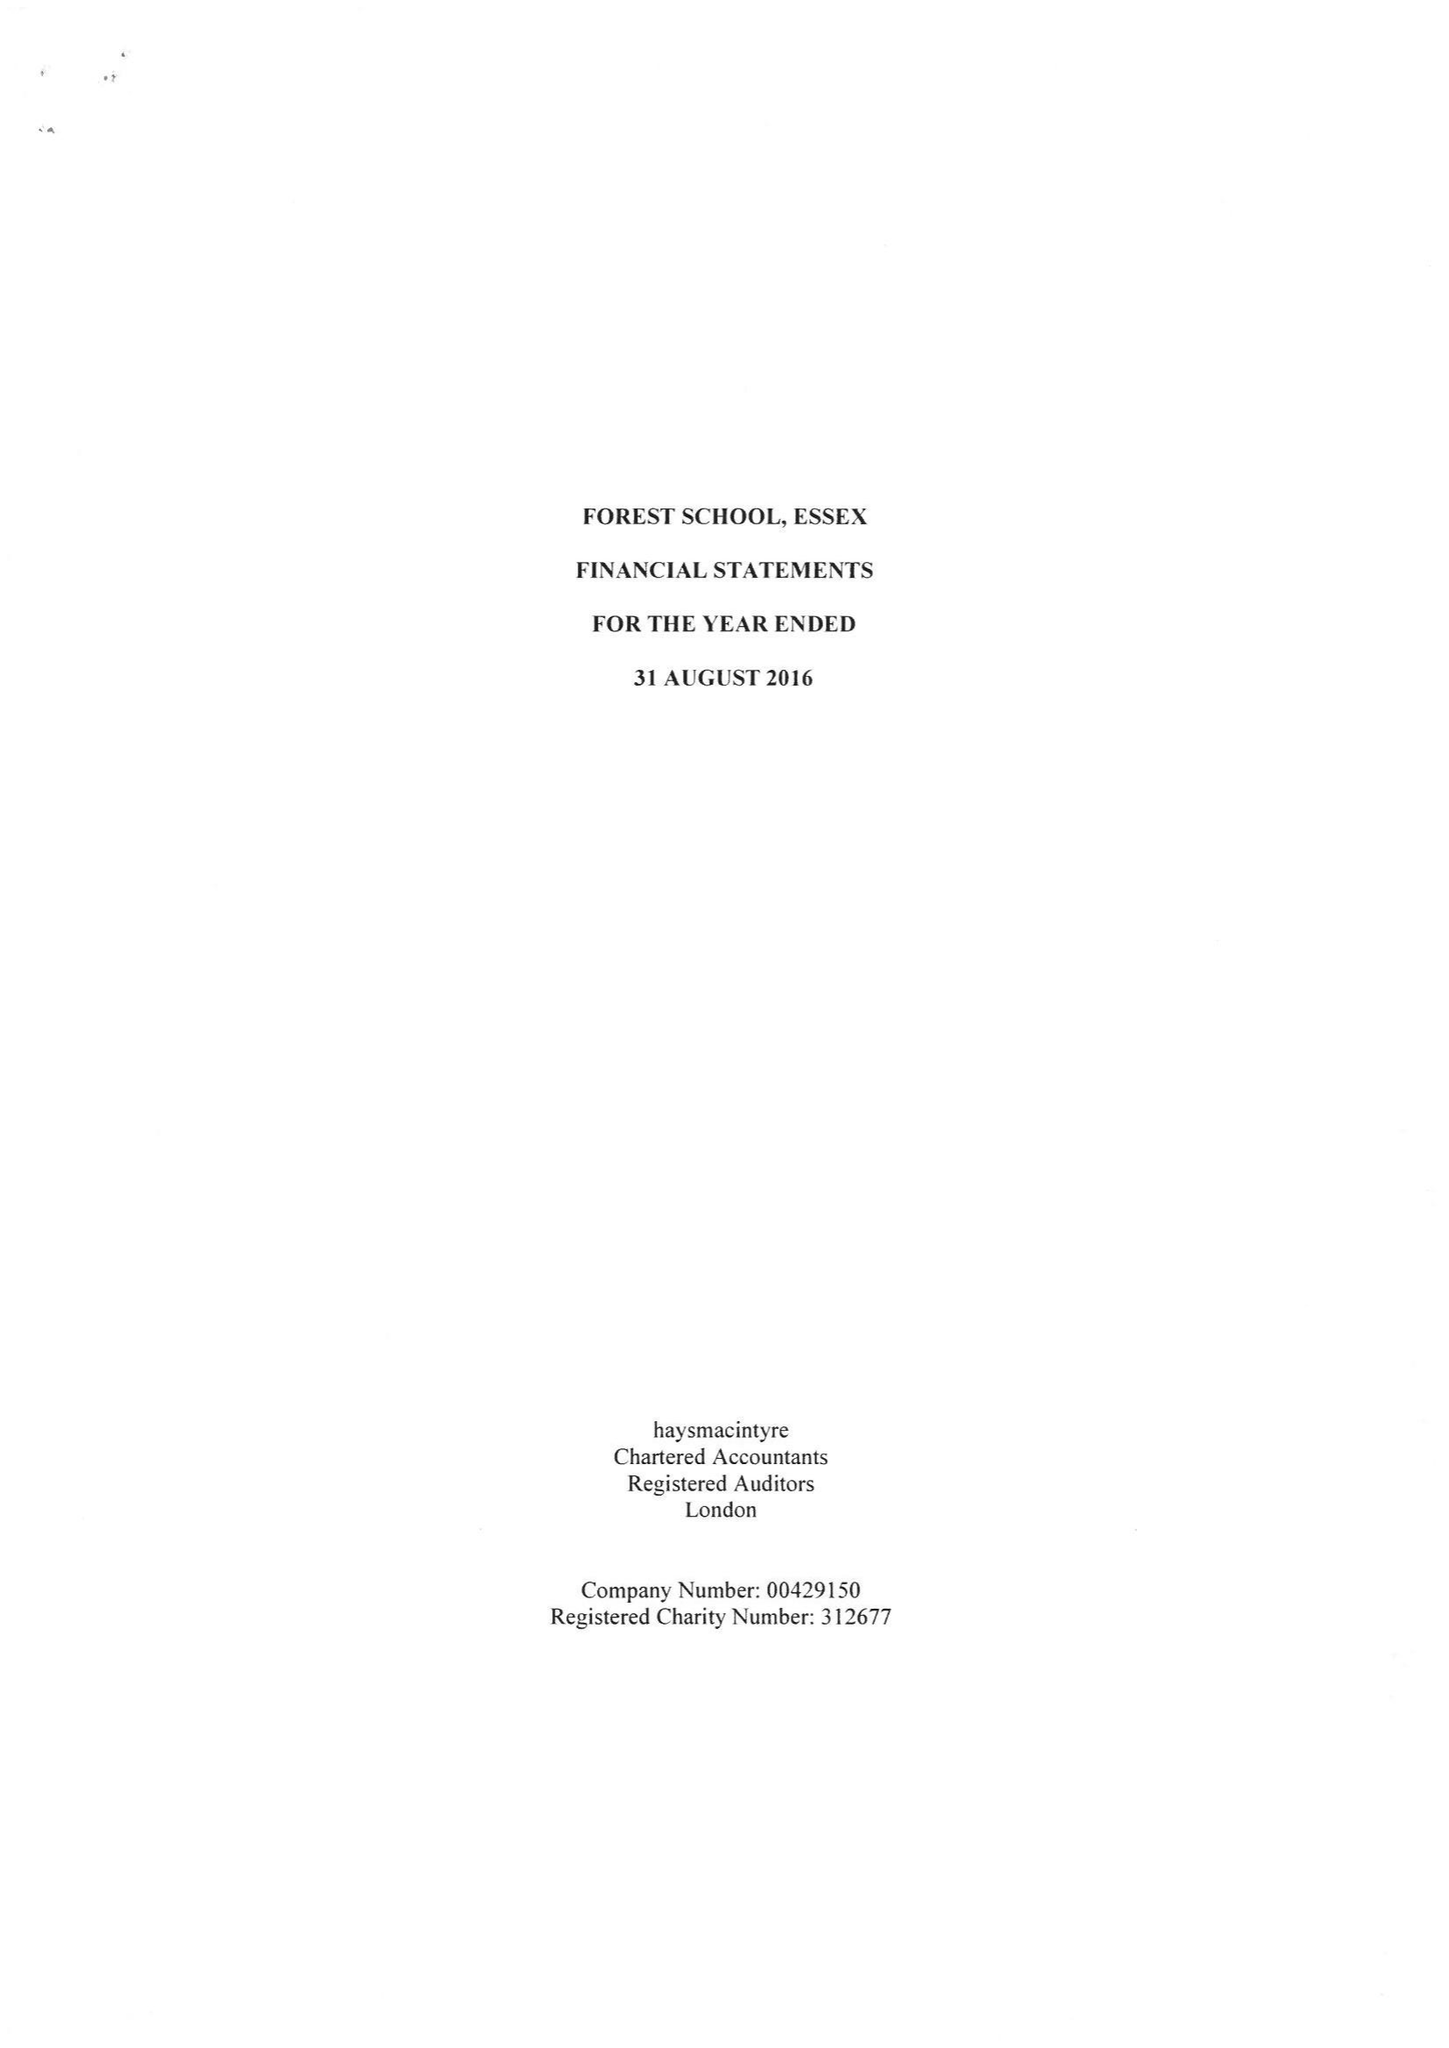What is the value for the charity_number?
Answer the question using a single word or phrase. 312677 